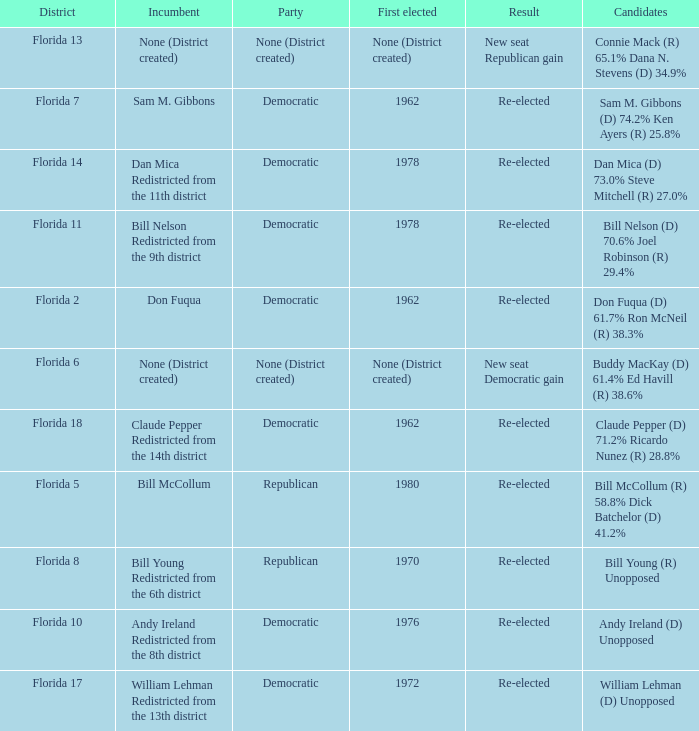 how many result with district being florida 14 1.0. 